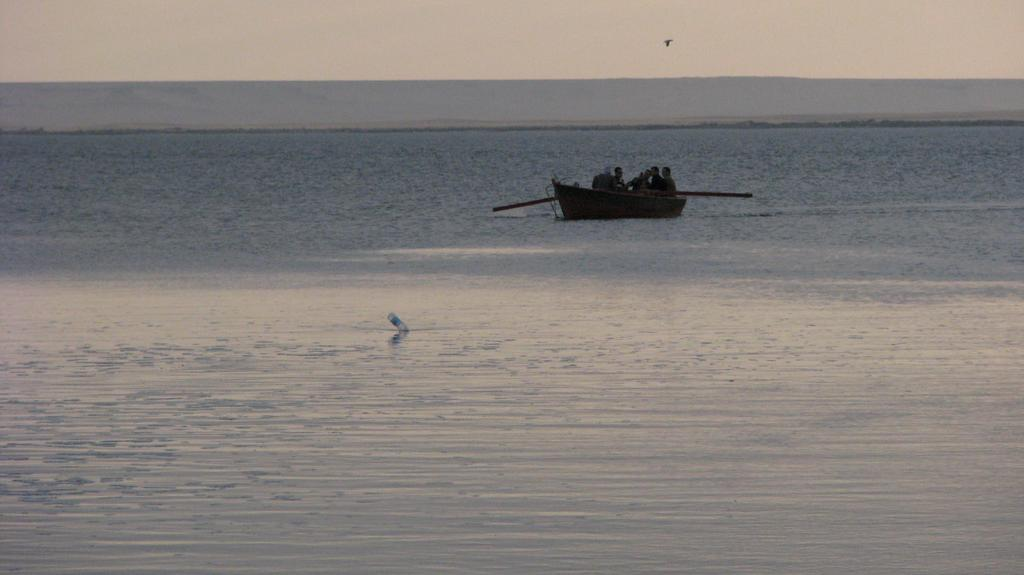What is the main subject of the image? The main subject of the image is water. What are the people in the image doing? The people are sitting on a boat in the image. What can be seen in the background of the image? The sky is visible in the image. What type of pencil can be seen being used to draw a curve in the image? There is no pencil or curve present in the image; it features water and people on a boat. 